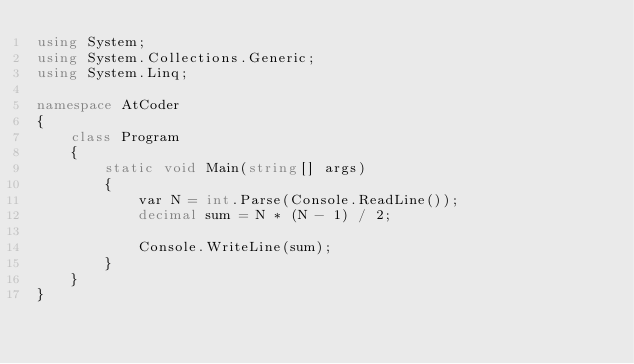Convert code to text. <code><loc_0><loc_0><loc_500><loc_500><_C#_>using System;
using System.Collections.Generic;
using System.Linq;

namespace AtCoder
{
    class Program
    {
        static void Main(string[] args)
        {
            var N = int.Parse(Console.ReadLine());
            decimal sum = N * (N - 1) / 2;

            Console.WriteLine(sum);
        }
    }
}
</code> 